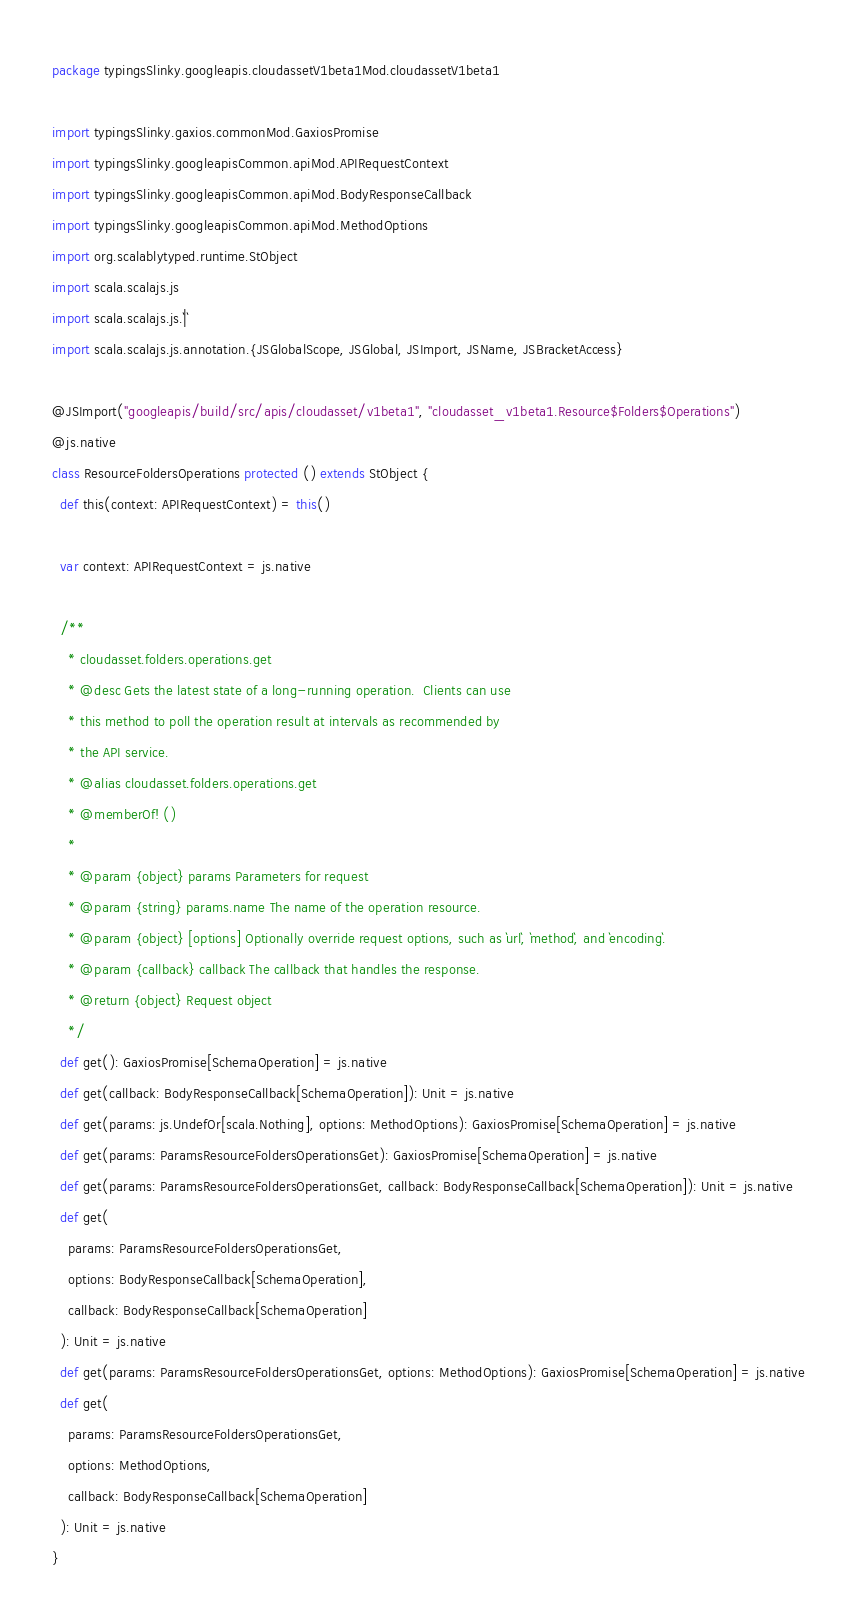<code> <loc_0><loc_0><loc_500><loc_500><_Scala_>package typingsSlinky.googleapis.cloudassetV1beta1Mod.cloudassetV1beta1

import typingsSlinky.gaxios.commonMod.GaxiosPromise
import typingsSlinky.googleapisCommon.apiMod.APIRequestContext
import typingsSlinky.googleapisCommon.apiMod.BodyResponseCallback
import typingsSlinky.googleapisCommon.apiMod.MethodOptions
import org.scalablytyped.runtime.StObject
import scala.scalajs.js
import scala.scalajs.js.`|`
import scala.scalajs.js.annotation.{JSGlobalScope, JSGlobal, JSImport, JSName, JSBracketAccess}

@JSImport("googleapis/build/src/apis/cloudasset/v1beta1", "cloudasset_v1beta1.Resource$Folders$Operations")
@js.native
class ResourceFoldersOperations protected () extends StObject {
  def this(context: APIRequestContext) = this()
  
  var context: APIRequestContext = js.native
  
  /**
    * cloudasset.folders.operations.get
    * @desc Gets the latest state of a long-running operation.  Clients can use
    * this method to poll the operation result at intervals as recommended by
    * the API service.
    * @alias cloudasset.folders.operations.get
    * @memberOf! ()
    *
    * @param {object} params Parameters for request
    * @param {string} params.name The name of the operation resource.
    * @param {object} [options] Optionally override request options, such as `url`, `method`, and `encoding`.
    * @param {callback} callback The callback that handles the response.
    * @return {object} Request object
    */
  def get(): GaxiosPromise[SchemaOperation] = js.native
  def get(callback: BodyResponseCallback[SchemaOperation]): Unit = js.native
  def get(params: js.UndefOr[scala.Nothing], options: MethodOptions): GaxiosPromise[SchemaOperation] = js.native
  def get(params: ParamsResourceFoldersOperationsGet): GaxiosPromise[SchemaOperation] = js.native
  def get(params: ParamsResourceFoldersOperationsGet, callback: BodyResponseCallback[SchemaOperation]): Unit = js.native
  def get(
    params: ParamsResourceFoldersOperationsGet,
    options: BodyResponseCallback[SchemaOperation],
    callback: BodyResponseCallback[SchemaOperation]
  ): Unit = js.native
  def get(params: ParamsResourceFoldersOperationsGet, options: MethodOptions): GaxiosPromise[SchemaOperation] = js.native
  def get(
    params: ParamsResourceFoldersOperationsGet,
    options: MethodOptions,
    callback: BodyResponseCallback[SchemaOperation]
  ): Unit = js.native
}
</code> 